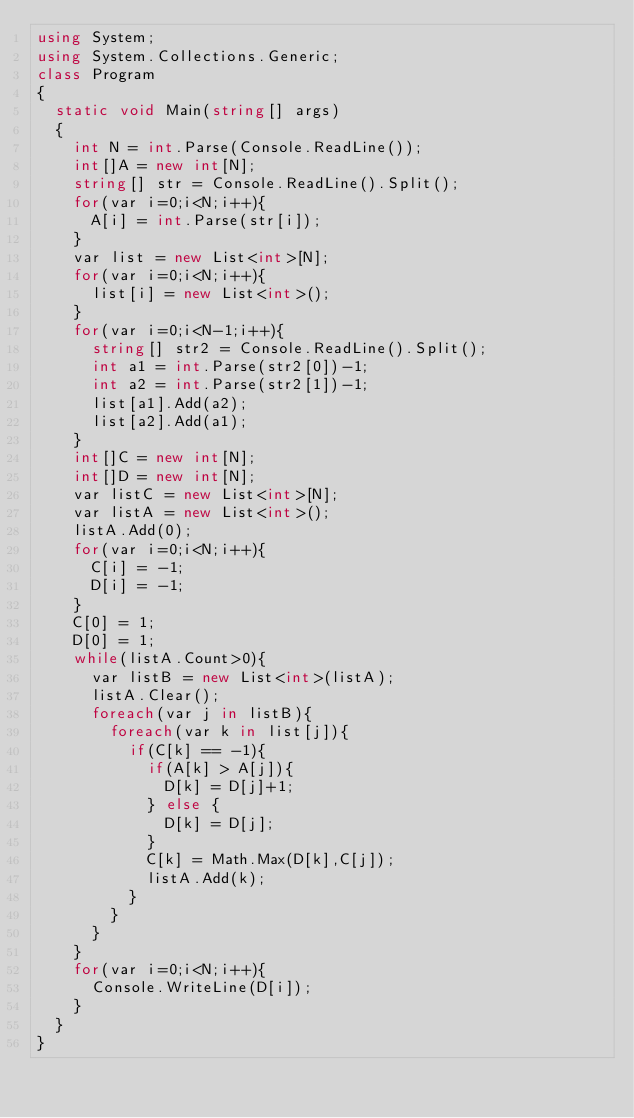<code> <loc_0><loc_0><loc_500><loc_500><_C#_>using System;
using System.Collections.Generic;
class Program
{
	static void Main(string[] args)
	{
		int N = int.Parse(Console.ReadLine());
		int[]A = new int[N];
		string[] str = Console.ReadLine().Split();
		for(var i=0;i<N;i++){
			A[i] = int.Parse(str[i]);
		}
		var list = new List<int>[N];
		for(var i=0;i<N;i++){
			list[i] = new List<int>();
		}
		for(var i=0;i<N-1;i++){
			string[] str2 = Console.ReadLine().Split();
			int a1 = int.Parse(str2[0])-1;
			int a2 = int.Parse(str2[1])-1;
			list[a1].Add(a2);
			list[a2].Add(a1);
		}
		int[]C = new int[N];
		int[]D = new int[N];
		var listC = new List<int>[N];
		var listA = new List<int>();
		listA.Add(0);
		for(var i=0;i<N;i++){
			C[i] = -1;
			D[i] = -1;
		}
		C[0] = 1;
		D[0] = 1;
		while(listA.Count>0){
			var listB = new List<int>(listA);
			listA.Clear();
			foreach(var j in listB){
				foreach(var k in list[j]){
					if(C[k] == -1){
						if(A[k] > A[j]){
							D[k] = D[j]+1;
						} else {
							D[k] = D[j];
						}
						C[k] = Math.Max(D[k],C[j]);
						listA.Add(k);
					}
				}
			}
		}
		for(var i=0;i<N;i++){
			Console.WriteLine(D[i]);
		}
	}
}</code> 